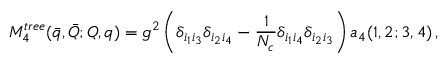<formula> <loc_0><loc_0><loc_500><loc_500>M _ { 4 } ^ { t r e e } ( \bar { q } , \bar { Q } ; Q , q ) = g ^ { 2 } \left ( \delta _ { i _ { 1 } i _ { 3 } } \delta _ { i _ { 2 } i _ { 4 } } - { \frac { 1 } { N _ { c } } } \delta _ { i _ { 1 } i _ { 4 } } \delta _ { i _ { 2 } i _ { 3 } } \right ) a _ { 4 } ( 1 , 2 ; 3 , 4 ) \, ,</formula> 